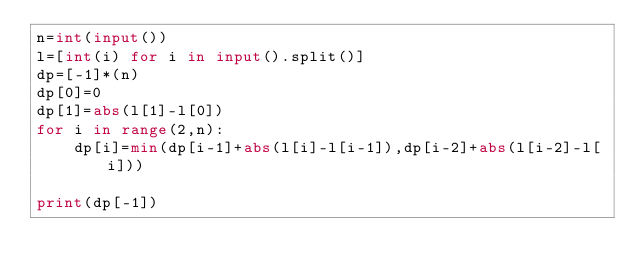Convert code to text. <code><loc_0><loc_0><loc_500><loc_500><_Python_>n=int(input())
l=[int(i) for i in input().split()]
dp=[-1]*(n)
dp[0]=0
dp[1]=abs(l[1]-l[0])
for i in range(2,n):
    dp[i]=min(dp[i-1]+abs(l[i]-l[i-1]),dp[i-2]+abs(l[i-2]-l[i]))
            
print(dp[-1])
</code> 